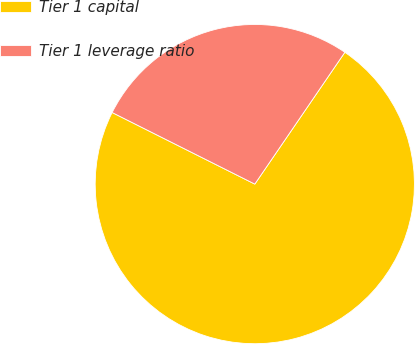Convert chart to OTSL. <chart><loc_0><loc_0><loc_500><loc_500><pie_chart><fcel>Tier 1 capital<fcel>Tier 1 leverage ratio<nl><fcel>72.86%<fcel>27.14%<nl></chart> 